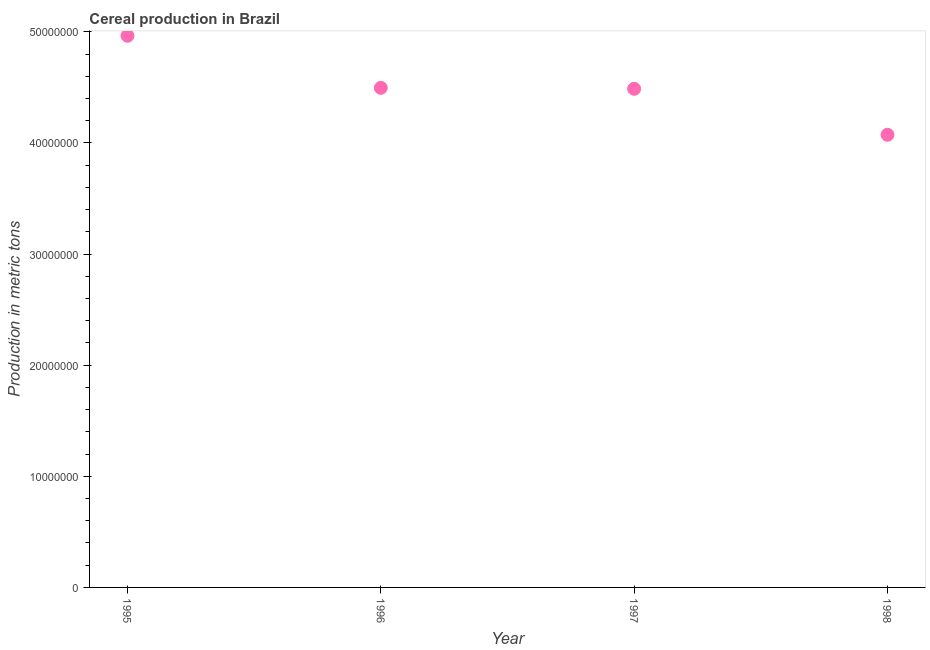What is the cereal production in 1998?
Give a very brief answer. 4.07e+07. Across all years, what is the maximum cereal production?
Give a very brief answer. 4.96e+07. Across all years, what is the minimum cereal production?
Make the answer very short. 4.07e+07. What is the sum of the cereal production?
Your answer should be compact. 1.80e+08. What is the difference between the cereal production in 1995 and 1998?
Give a very brief answer. 8.91e+06. What is the average cereal production per year?
Keep it short and to the point. 4.51e+07. What is the median cereal production?
Make the answer very short. 4.49e+07. In how many years, is the cereal production greater than 10000000 metric tons?
Your answer should be compact. 4. Do a majority of the years between 1997 and 1998 (inclusive) have cereal production greater than 34000000 metric tons?
Your response must be concise. Yes. What is the ratio of the cereal production in 1995 to that in 1996?
Ensure brevity in your answer.  1.1. Is the cereal production in 1996 less than that in 1997?
Your answer should be very brief. No. Is the difference between the cereal production in 1995 and 1996 greater than the difference between any two years?
Provide a succinct answer. No. What is the difference between the highest and the second highest cereal production?
Provide a succinct answer. 4.68e+06. Is the sum of the cereal production in 1996 and 1997 greater than the maximum cereal production across all years?
Your response must be concise. Yes. What is the difference between the highest and the lowest cereal production?
Your response must be concise. 8.91e+06. How many years are there in the graph?
Offer a very short reply. 4. What is the difference between two consecutive major ticks on the Y-axis?
Offer a very short reply. 1.00e+07. Are the values on the major ticks of Y-axis written in scientific E-notation?
Ensure brevity in your answer.  No. Does the graph contain any zero values?
Offer a terse response. No. What is the title of the graph?
Offer a very short reply. Cereal production in Brazil. What is the label or title of the X-axis?
Your response must be concise. Year. What is the label or title of the Y-axis?
Make the answer very short. Production in metric tons. What is the Production in metric tons in 1995?
Offer a terse response. 4.96e+07. What is the Production in metric tons in 1996?
Give a very brief answer. 4.50e+07. What is the Production in metric tons in 1997?
Offer a very short reply. 4.49e+07. What is the Production in metric tons in 1998?
Your answer should be very brief. 4.07e+07. What is the difference between the Production in metric tons in 1995 and 1996?
Offer a very short reply. 4.68e+06. What is the difference between the Production in metric tons in 1995 and 1997?
Give a very brief answer. 4.77e+06. What is the difference between the Production in metric tons in 1995 and 1998?
Your answer should be compact. 8.91e+06. What is the difference between the Production in metric tons in 1996 and 1997?
Give a very brief answer. 8.59e+04. What is the difference between the Production in metric tons in 1996 and 1998?
Your answer should be very brief. 4.22e+06. What is the difference between the Production in metric tons in 1997 and 1998?
Your answer should be very brief. 4.14e+06. What is the ratio of the Production in metric tons in 1995 to that in 1996?
Provide a short and direct response. 1.1. What is the ratio of the Production in metric tons in 1995 to that in 1997?
Your response must be concise. 1.11. What is the ratio of the Production in metric tons in 1995 to that in 1998?
Offer a terse response. 1.22. What is the ratio of the Production in metric tons in 1996 to that in 1998?
Ensure brevity in your answer.  1.1. What is the ratio of the Production in metric tons in 1997 to that in 1998?
Offer a very short reply. 1.1. 